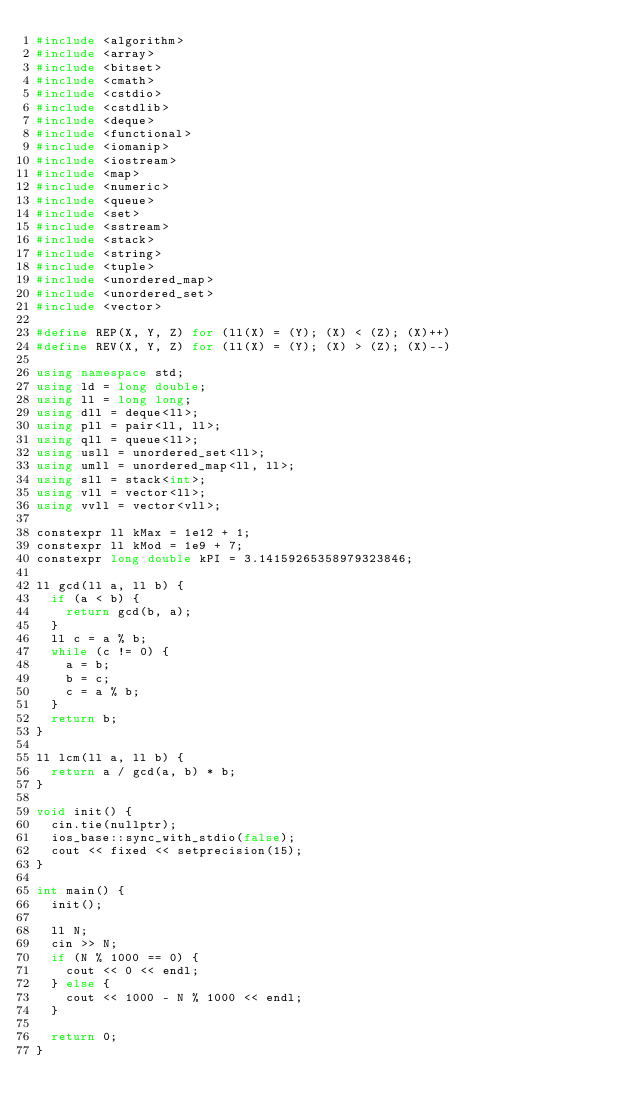Convert code to text. <code><loc_0><loc_0><loc_500><loc_500><_C++_>#include <algorithm>
#include <array>
#include <bitset>
#include <cmath>
#include <cstdio>
#include <cstdlib>
#include <deque>
#include <functional>
#include <iomanip>
#include <iostream>
#include <map>
#include <numeric>
#include <queue>
#include <set>
#include <sstream>
#include <stack>
#include <string>
#include <tuple>
#include <unordered_map>
#include <unordered_set>
#include <vector>

#define REP(X, Y, Z) for (ll(X) = (Y); (X) < (Z); (X)++)
#define REV(X, Y, Z) for (ll(X) = (Y); (X) > (Z); (X)--)

using namespace std;
using ld = long double;
using ll = long long;
using dll = deque<ll>;
using pll = pair<ll, ll>;
using qll = queue<ll>;
using usll = unordered_set<ll>;
using umll = unordered_map<ll, ll>;
using sll = stack<int>;
using vll = vector<ll>;
using vvll = vector<vll>;

constexpr ll kMax = 1e12 + 1;
constexpr ll kMod = 1e9 + 7;
constexpr long double kPI = 3.14159265358979323846;

ll gcd(ll a, ll b) {
  if (a < b) {
    return gcd(b, a);
  }
  ll c = a % b;
  while (c != 0) {
    a = b;
    b = c;
    c = a % b;
  }
  return b;
}

ll lcm(ll a, ll b) {
  return a / gcd(a, b) * b;
}

void init() {
  cin.tie(nullptr);
  ios_base::sync_with_stdio(false);
  cout << fixed << setprecision(15);
}

int main() {
  init();

  ll N;
  cin >> N;
  if (N % 1000 == 0) {
    cout << 0 << endl;
  } else {
    cout << 1000 - N % 1000 << endl;
  }

  return 0;
}
</code> 